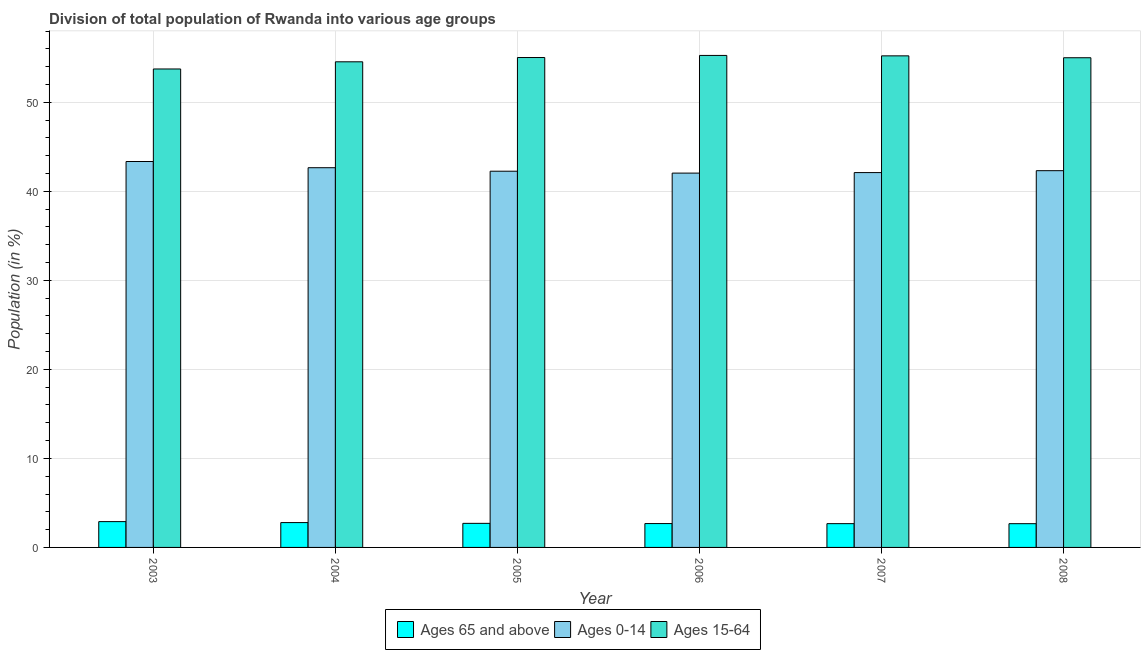How many different coloured bars are there?
Keep it short and to the point. 3. How many groups of bars are there?
Offer a terse response. 6. Are the number of bars on each tick of the X-axis equal?
Offer a very short reply. Yes. How many bars are there on the 1st tick from the right?
Provide a succinct answer. 3. In how many cases, is the number of bars for a given year not equal to the number of legend labels?
Keep it short and to the point. 0. What is the percentage of population within the age-group of 65 and above in 2003?
Keep it short and to the point. 2.9. Across all years, what is the maximum percentage of population within the age-group 15-64?
Your response must be concise. 55.27. Across all years, what is the minimum percentage of population within the age-group 0-14?
Keep it short and to the point. 42.05. In which year was the percentage of population within the age-group of 65 and above minimum?
Make the answer very short. 2008. What is the total percentage of population within the age-group of 65 and above in the graph?
Your answer should be compact. 16.42. What is the difference between the percentage of population within the age-group of 65 and above in 2003 and that in 2008?
Offer a very short reply. 0.23. What is the difference between the percentage of population within the age-group of 65 and above in 2006 and the percentage of population within the age-group 0-14 in 2005?
Your answer should be compact. -0.02. What is the average percentage of population within the age-group 0-14 per year?
Your response must be concise. 42.46. In the year 2008, what is the difference between the percentage of population within the age-group of 65 and above and percentage of population within the age-group 15-64?
Your answer should be compact. 0. What is the ratio of the percentage of population within the age-group 15-64 in 2004 to that in 2007?
Offer a very short reply. 0.99. Is the percentage of population within the age-group 0-14 in 2004 less than that in 2008?
Ensure brevity in your answer.  No. What is the difference between the highest and the second highest percentage of population within the age-group 0-14?
Your answer should be compact. 0.7. What is the difference between the highest and the lowest percentage of population within the age-group 15-64?
Provide a succinct answer. 1.52. What does the 1st bar from the left in 2007 represents?
Your answer should be very brief. Ages 65 and above. What does the 2nd bar from the right in 2008 represents?
Give a very brief answer. Ages 0-14. Is it the case that in every year, the sum of the percentage of population within the age-group of 65 and above and percentage of population within the age-group 0-14 is greater than the percentage of population within the age-group 15-64?
Ensure brevity in your answer.  No. How many bars are there?
Give a very brief answer. 18. How many years are there in the graph?
Ensure brevity in your answer.  6. What is the difference between two consecutive major ticks on the Y-axis?
Keep it short and to the point. 10. Are the values on the major ticks of Y-axis written in scientific E-notation?
Your response must be concise. No. Does the graph contain grids?
Ensure brevity in your answer.  Yes. Where does the legend appear in the graph?
Offer a very short reply. Bottom center. How many legend labels are there?
Ensure brevity in your answer.  3. How are the legend labels stacked?
Provide a succinct answer. Horizontal. What is the title of the graph?
Your answer should be very brief. Division of total population of Rwanda into various age groups
. What is the Population (in %) in Ages 65 and above in 2003?
Your response must be concise. 2.9. What is the Population (in %) in Ages 0-14 in 2003?
Keep it short and to the point. 43.35. What is the Population (in %) of Ages 15-64 in 2003?
Your answer should be compact. 53.75. What is the Population (in %) in Ages 65 and above in 2004?
Your answer should be very brief. 2.79. What is the Population (in %) in Ages 0-14 in 2004?
Your answer should be very brief. 42.66. What is the Population (in %) in Ages 15-64 in 2004?
Make the answer very short. 54.55. What is the Population (in %) in Ages 65 and above in 2005?
Keep it short and to the point. 2.71. What is the Population (in %) in Ages 0-14 in 2005?
Give a very brief answer. 42.26. What is the Population (in %) of Ages 15-64 in 2005?
Provide a short and direct response. 55.03. What is the Population (in %) in Ages 65 and above in 2006?
Provide a succinct answer. 2.68. What is the Population (in %) in Ages 0-14 in 2006?
Offer a very short reply. 42.05. What is the Population (in %) of Ages 15-64 in 2006?
Offer a very short reply. 55.27. What is the Population (in %) of Ages 65 and above in 2007?
Provide a succinct answer. 2.67. What is the Population (in %) in Ages 0-14 in 2007?
Give a very brief answer. 42.11. What is the Population (in %) of Ages 15-64 in 2007?
Provide a succinct answer. 55.22. What is the Population (in %) of Ages 65 and above in 2008?
Your answer should be compact. 2.67. What is the Population (in %) in Ages 0-14 in 2008?
Offer a very short reply. 42.32. What is the Population (in %) of Ages 15-64 in 2008?
Give a very brief answer. 55.01. Across all years, what is the maximum Population (in %) of Ages 65 and above?
Offer a very short reply. 2.9. Across all years, what is the maximum Population (in %) in Ages 0-14?
Your response must be concise. 43.35. Across all years, what is the maximum Population (in %) of Ages 15-64?
Offer a very short reply. 55.27. Across all years, what is the minimum Population (in %) in Ages 65 and above?
Your answer should be compact. 2.67. Across all years, what is the minimum Population (in %) of Ages 0-14?
Provide a succinct answer. 42.05. Across all years, what is the minimum Population (in %) in Ages 15-64?
Provide a short and direct response. 53.75. What is the total Population (in %) of Ages 65 and above in the graph?
Give a very brief answer. 16.42. What is the total Population (in %) of Ages 0-14 in the graph?
Make the answer very short. 254.75. What is the total Population (in %) of Ages 15-64 in the graph?
Ensure brevity in your answer.  328.83. What is the difference between the Population (in %) of Ages 65 and above in 2003 and that in 2004?
Your answer should be very brief. 0.11. What is the difference between the Population (in %) in Ages 0-14 in 2003 and that in 2004?
Keep it short and to the point. 0.7. What is the difference between the Population (in %) in Ages 15-64 in 2003 and that in 2004?
Your answer should be compact. -0.8. What is the difference between the Population (in %) of Ages 65 and above in 2003 and that in 2005?
Give a very brief answer. 0.19. What is the difference between the Population (in %) of Ages 0-14 in 2003 and that in 2005?
Your answer should be compact. 1.09. What is the difference between the Population (in %) of Ages 15-64 in 2003 and that in 2005?
Give a very brief answer. -1.29. What is the difference between the Population (in %) of Ages 65 and above in 2003 and that in 2006?
Provide a short and direct response. 0.22. What is the difference between the Population (in %) of Ages 0-14 in 2003 and that in 2006?
Keep it short and to the point. 1.3. What is the difference between the Population (in %) in Ages 15-64 in 2003 and that in 2006?
Offer a very short reply. -1.52. What is the difference between the Population (in %) of Ages 65 and above in 2003 and that in 2007?
Your answer should be very brief. 0.23. What is the difference between the Population (in %) of Ages 0-14 in 2003 and that in 2007?
Your answer should be very brief. 1.24. What is the difference between the Population (in %) in Ages 15-64 in 2003 and that in 2007?
Your response must be concise. -1.47. What is the difference between the Population (in %) in Ages 65 and above in 2003 and that in 2008?
Provide a short and direct response. 0.23. What is the difference between the Population (in %) in Ages 0-14 in 2003 and that in 2008?
Ensure brevity in your answer.  1.03. What is the difference between the Population (in %) in Ages 15-64 in 2003 and that in 2008?
Ensure brevity in your answer.  -1.26. What is the difference between the Population (in %) in Ages 65 and above in 2004 and that in 2005?
Keep it short and to the point. 0.09. What is the difference between the Population (in %) of Ages 0-14 in 2004 and that in 2005?
Your answer should be very brief. 0.39. What is the difference between the Population (in %) of Ages 15-64 in 2004 and that in 2005?
Your answer should be compact. -0.48. What is the difference between the Population (in %) in Ages 65 and above in 2004 and that in 2006?
Your response must be concise. 0.11. What is the difference between the Population (in %) in Ages 0-14 in 2004 and that in 2006?
Provide a short and direct response. 0.61. What is the difference between the Population (in %) in Ages 15-64 in 2004 and that in 2006?
Offer a very short reply. -0.72. What is the difference between the Population (in %) of Ages 65 and above in 2004 and that in 2007?
Make the answer very short. 0.12. What is the difference between the Population (in %) in Ages 0-14 in 2004 and that in 2007?
Ensure brevity in your answer.  0.55. What is the difference between the Population (in %) in Ages 15-64 in 2004 and that in 2007?
Your answer should be compact. -0.67. What is the difference between the Population (in %) of Ages 65 and above in 2004 and that in 2008?
Give a very brief answer. 0.12. What is the difference between the Population (in %) of Ages 0-14 in 2004 and that in 2008?
Give a very brief answer. 0.33. What is the difference between the Population (in %) in Ages 15-64 in 2004 and that in 2008?
Provide a short and direct response. -0.46. What is the difference between the Population (in %) of Ages 65 and above in 2005 and that in 2006?
Ensure brevity in your answer.  0.02. What is the difference between the Population (in %) of Ages 0-14 in 2005 and that in 2006?
Keep it short and to the point. 0.21. What is the difference between the Population (in %) of Ages 15-64 in 2005 and that in 2006?
Provide a short and direct response. -0.24. What is the difference between the Population (in %) in Ages 65 and above in 2005 and that in 2007?
Your answer should be compact. 0.03. What is the difference between the Population (in %) in Ages 0-14 in 2005 and that in 2007?
Provide a short and direct response. 0.15. What is the difference between the Population (in %) in Ages 15-64 in 2005 and that in 2007?
Keep it short and to the point. -0.19. What is the difference between the Population (in %) in Ages 65 and above in 2005 and that in 2008?
Offer a terse response. 0.04. What is the difference between the Population (in %) of Ages 0-14 in 2005 and that in 2008?
Make the answer very short. -0.06. What is the difference between the Population (in %) in Ages 15-64 in 2005 and that in 2008?
Offer a terse response. 0.02. What is the difference between the Population (in %) of Ages 65 and above in 2006 and that in 2007?
Offer a very short reply. 0.01. What is the difference between the Population (in %) of Ages 0-14 in 2006 and that in 2007?
Your response must be concise. -0.06. What is the difference between the Population (in %) in Ages 15-64 in 2006 and that in 2007?
Your answer should be very brief. 0.05. What is the difference between the Population (in %) of Ages 65 and above in 2006 and that in 2008?
Offer a terse response. 0.01. What is the difference between the Population (in %) of Ages 0-14 in 2006 and that in 2008?
Your response must be concise. -0.27. What is the difference between the Population (in %) in Ages 15-64 in 2006 and that in 2008?
Ensure brevity in your answer.  0.26. What is the difference between the Population (in %) of Ages 65 and above in 2007 and that in 2008?
Provide a short and direct response. 0. What is the difference between the Population (in %) in Ages 0-14 in 2007 and that in 2008?
Make the answer very short. -0.21. What is the difference between the Population (in %) in Ages 15-64 in 2007 and that in 2008?
Your answer should be compact. 0.21. What is the difference between the Population (in %) in Ages 65 and above in 2003 and the Population (in %) in Ages 0-14 in 2004?
Offer a terse response. -39.76. What is the difference between the Population (in %) in Ages 65 and above in 2003 and the Population (in %) in Ages 15-64 in 2004?
Your response must be concise. -51.65. What is the difference between the Population (in %) in Ages 0-14 in 2003 and the Population (in %) in Ages 15-64 in 2004?
Give a very brief answer. -11.2. What is the difference between the Population (in %) in Ages 65 and above in 2003 and the Population (in %) in Ages 0-14 in 2005?
Offer a terse response. -39.36. What is the difference between the Population (in %) of Ages 65 and above in 2003 and the Population (in %) of Ages 15-64 in 2005?
Provide a short and direct response. -52.13. What is the difference between the Population (in %) of Ages 0-14 in 2003 and the Population (in %) of Ages 15-64 in 2005?
Ensure brevity in your answer.  -11.68. What is the difference between the Population (in %) in Ages 65 and above in 2003 and the Population (in %) in Ages 0-14 in 2006?
Provide a succinct answer. -39.15. What is the difference between the Population (in %) in Ages 65 and above in 2003 and the Population (in %) in Ages 15-64 in 2006?
Your response must be concise. -52.37. What is the difference between the Population (in %) of Ages 0-14 in 2003 and the Population (in %) of Ages 15-64 in 2006?
Your answer should be compact. -11.92. What is the difference between the Population (in %) in Ages 65 and above in 2003 and the Population (in %) in Ages 0-14 in 2007?
Ensure brevity in your answer.  -39.21. What is the difference between the Population (in %) in Ages 65 and above in 2003 and the Population (in %) in Ages 15-64 in 2007?
Offer a very short reply. -52.32. What is the difference between the Population (in %) in Ages 0-14 in 2003 and the Population (in %) in Ages 15-64 in 2007?
Provide a succinct answer. -11.87. What is the difference between the Population (in %) of Ages 65 and above in 2003 and the Population (in %) of Ages 0-14 in 2008?
Offer a very short reply. -39.42. What is the difference between the Population (in %) in Ages 65 and above in 2003 and the Population (in %) in Ages 15-64 in 2008?
Give a very brief answer. -52.11. What is the difference between the Population (in %) of Ages 0-14 in 2003 and the Population (in %) of Ages 15-64 in 2008?
Make the answer very short. -11.66. What is the difference between the Population (in %) of Ages 65 and above in 2004 and the Population (in %) of Ages 0-14 in 2005?
Your answer should be compact. -39.47. What is the difference between the Population (in %) of Ages 65 and above in 2004 and the Population (in %) of Ages 15-64 in 2005?
Provide a short and direct response. -52.24. What is the difference between the Population (in %) of Ages 0-14 in 2004 and the Population (in %) of Ages 15-64 in 2005?
Your response must be concise. -12.38. What is the difference between the Population (in %) of Ages 65 and above in 2004 and the Population (in %) of Ages 0-14 in 2006?
Make the answer very short. -39.26. What is the difference between the Population (in %) in Ages 65 and above in 2004 and the Population (in %) in Ages 15-64 in 2006?
Your response must be concise. -52.48. What is the difference between the Population (in %) of Ages 0-14 in 2004 and the Population (in %) of Ages 15-64 in 2006?
Make the answer very short. -12.61. What is the difference between the Population (in %) of Ages 65 and above in 2004 and the Population (in %) of Ages 0-14 in 2007?
Provide a short and direct response. -39.32. What is the difference between the Population (in %) in Ages 65 and above in 2004 and the Population (in %) in Ages 15-64 in 2007?
Provide a succinct answer. -52.43. What is the difference between the Population (in %) of Ages 0-14 in 2004 and the Population (in %) of Ages 15-64 in 2007?
Make the answer very short. -12.57. What is the difference between the Population (in %) of Ages 65 and above in 2004 and the Population (in %) of Ages 0-14 in 2008?
Offer a very short reply. -39.53. What is the difference between the Population (in %) of Ages 65 and above in 2004 and the Population (in %) of Ages 15-64 in 2008?
Ensure brevity in your answer.  -52.22. What is the difference between the Population (in %) of Ages 0-14 in 2004 and the Population (in %) of Ages 15-64 in 2008?
Keep it short and to the point. -12.35. What is the difference between the Population (in %) in Ages 65 and above in 2005 and the Population (in %) in Ages 0-14 in 2006?
Give a very brief answer. -39.35. What is the difference between the Population (in %) in Ages 65 and above in 2005 and the Population (in %) in Ages 15-64 in 2006?
Offer a terse response. -52.56. What is the difference between the Population (in %) of Ages 0-14 in 2005 and the Population (in %) of Ages 15-64 in 2006?
Keep it short and to the point. -13.01. What is the difference between the Population (in %) in Ages 65 and above in 2005 and the Population (in %) in Ages 0-14 in 2007?
Your answer should be compact. -39.4. What is the difference between the Population (in %) in Ages 65 and above in 2005 and the Population (in %) in Ages 15-64 in 2007?
Keep it short and to the point. -52.52. What is the difference between the Population (in %) in Ages 0-14 in 2005 and the Population (in %) in Ages 15-64 in 2007?
Give a very brief answer. -12.96. What is the difference between the Population (in %) of Ages 65 and above in 2005 and the Population (in %) of Ages 0-14 in 2008?
Offer a terse response. -39.62. What is the difference between the Population (in %) of Ages 65 and above in 2005 and the Population (in %) of Ages 15-64 in 2008?
Offer a terse response. -52.3. What is the difference between the Population (in %) in Ages 0-14 in 2005 and the Population (in %) in Ages 15-64 in 2008?
Give a very brief answer. -12.75. What is the difference between the Population (in %) of Ages 65 and above in 2006 and the Population (in %) of Ages 0-14 in 2007?
Your response must be concise. -39.43. What is the difference between the Population (in %) in Ages 65 and above in 2006 and the Population (in %) in Ages 15-64 in 2007?
Give a very brief answer. -52.54. What is the difference between the Population (in %) of Ages 0-14 in 2006 and the Population (in %) of Ages 15-64 in 2007?
Keep it short and to the point. -13.17. What is the difference between the Population (in %) of Ages 65 and above in 2006 and the Population (in %) of Ages 0-14 in 2008?
Make the answer very short. -39.64. What is the difference between the Population (in %) in Ages 65 and above in 2006 and the Population (in %) in Ages 15-64 in 2008?
Offer a terse response. -52.33. What is the difference between the Population (in %) in Ages 0-14 in 2006 and the Population (in %) in Ages 15-64 in 2008?
Your answer should be compact. -12.96. What is the difference between the Population (in %) of Ages 65 and above in 2007 and the Population (in %) of Ages 0-14 in 2008?
Offer a terse response. -39.65. What is the difference between the Population (in %) of Ages 65 and above in 2007 and the Population (in %) of Ages 15-64 in 2008?
Your answer should be compact. -52.34. What is the difference between the Population (in %) in Ages 0-14 in 2007 and the Population (in %) in Ages 15-64 in 2008?
Give a very brief answer. -12.9. What is the average Population (in %) of Ages 65 and above per year?
Make the answer very short. 2.74. What is the average Population (in %) in Ages 0-14 per year?
Your answer should be compact. 42.46. What is the average Population (in %) in Ages 15-64 per year?
Give a very brief answer. 54.81. In the year 2003, what is the difference between the Population (in %) of Ages 65 and above and Population (in %) of Ages 0-14?
Keep it short and to the point. -40.45. In the year 2003, what is the difference between the Population (in %) in Ages 65 and above and Population (in %) in Ages 15-64?
Provide a succinct answer. -50.85. In the year 2003, what is the difference between the Population (in %) in Ages 0-14 and Population (in %) in Ages 15-64?
Provide a succinct answer. -10.4. In the year 2004, what is the difference between the Population (in %) in Ages 65 and above and Population (in %) in Ages 0-14?
Your answer should be compact. -39.87. In the year 2004, what is the difference between the Population (in %) in Ages 65 and above and Population (in %) in Ages 15-64?
Offer a terse response. -51.76. In the year 2004, what is the difference between the Population (in %) in Ages 0-14 and Population (in %) in Ages 15-64?
Keep it short and to the point. -11.9. In the year 2005, what is the difference between the Population (in %) of Ages 65 and above and Population (in %) of Ages 0-14?
Provide a succinct answer. -39.56. In the year 2005, what is the difference between the Population (in %) of Ages 65 and above and Population (in %) of Ages 15-64?
Keep it short and to the point. -52.33. In the year 2005, what is the difference between the Population (in %) in Ages 0-14 and Population (in %) in Ages 15-64?
Offer a terse response. -12.77. In the year 2006, what is the difference between the Population (in %) in Ages 65 and above and Population (in %) in Ages 0-14?
Your answer should be very brief. -39.37. In the year 2006, what is the difference between the Population (in %) of Ages 65 and above and Population (in %) of Ages 15-64?
Offer a terse response. -52.59. In the year 2006, what is the difference between the Population (in %) in Ages 0-14 and Population (in %) in Ages 15-64?
Give a very brief answer. -13.22. In the year 2007, what is the difference between the Population (in %) in Ages 65 and above and Population (in %) in Ages 0-14?
Offer a very short reply. -39.44. In the year 2007, what is the difference between the Population (in %) of Ages 65 and above and Population (in %) of Ages 15-64?
Give a very brief answer. -52.55. In the year 2007, what is the difference between the Population (in %) in Ages 0-14 and Population (in %) in Ages 15-64?
Your response must be concise. -13.11. In the year 2008, what is the difference between the Population (in %) in Ages 65 and above and Population (in %) in Ages 0-14?
Provide a succinct answer. -39.65. In the year 2008, what is the difference between the Population (in %) in Ages 65 and above and Population (in %) in Ages 15-64?
Your answer should be compact. -52.34. In the year 2008, what is the difference between the Population (in %) in Ages 0-14 and Population (in %) in Ages 15-64?
Make the answer very short. -12.69. What is the ratio of the Population (in %) in Ages 65 and above in 2003 to that in 2004?
Keep it short and to the point. 1.04. What is the ratio of the Population (in %) in Ages 0-14 in 2003 to that in 2004?
Your answer should be very brief. 1.02. What is the ratio of the Population (in %) of Ages 15-64 in 2003 to that in 2004?
Make the answer very short. 0.99. What is the ratio of the Population (in %) in Ages 65 and above in 2003 to that in 2005?
Offer a terse response. 1.07. What is the ratio of the Population (in %) of Ages 0-14 in 2003 to that in 2005?
Keep it short and to the point. 1.03. What is the ratio of the Population (in %) of Ages 15-64 in 2003 to that in 2005?
Give a very brief answer. 0.98. What is the ratio of the Population (in %) in Ages 65 and above in 2003 to that in 2006?
Ensure brevity in your answer.  1.08. What is the ratio of the Population (in %) of Ages 0-14 in 2003 to that in 2006?
Keep it short and to the point. 1.03. What is the ratio of the Population (in %) in Ages 15-64 in 2003 to that in 2006?
Offer a terse response. 0.97. What is the ratio of the Population (in %) in Ages 65 and above in 2003 to that in 2007?
Keep it short and to the point. 1.09. What is the ratio of the Population (in %) in Ages 0-14 in 2003 to that in 2007?
Your response must be concise. 1.03. What is the ratio of the Population (in %) of Ages 15-64 in 2003 to that in 2007?
Keep it short and to the point. 0.97. What is the ratio of the Population (in %) of Ages 65 and above in 2003 to that in 2008?
Offer a very short reply. 1.09. What is the ratio of the Population (in %) in Ages 0-14 in 2003 to that in 2008?
Provide a short and direct response. 1.02. What is the ratio of the Population (in %) of Ages 15-64 in 2003 to that in 2008?
Ensure brevity in your answer.  0.98. What is the ratio of the Population (in %) in Ages 65 and above in 2004 to that in 2005?
Keep it short and to the point. 1.03. What is the ratio of the Population (in %) of Ages 0-14 in 2004 to that in 2005?
Your response must be concise. 1.01. What is the ratio of the Population (in %) in Ages 15-64 in 2004 to that in 2005?
Ensure brevity in your answer.  0.99. What is the ratio of the Population (in %) in Ages 65 and above in 2004 to that in 2006?
Provide a succinct answer. 1.04. What is the ratio of the Population (in %) in Ages 0-14 in 2004 to that in 2006?
Your answer should be very brief. 1.01. What is the ratio of the Population (in %) in Ages 15-64 in 2004 to that in 2006?
Make the answer very short. 0.99. What is the ratio of the Population (in %) in Ages 65 and above in 2004 to that in 2007?
Your answer should be very brief. 1.05. What is the ratio of the Population (in %) in Ages 0-14 in 2004 to that in 2007?
Your response must be concise. 1.01. What is the ratio of the Population (in %) in Ages 15-64 in 2004 to that in 2007?
Make the answer very short. 0.99. What is the ratio of the Population (in %) of Ages 65 and above in 2004 to that in 2008?
Ensure brevity in your answer.  1.05. What is the ratio of the Population (in %) of Ages 0-14 in 2004 to that in 2008?
Offer a very short reply. 1.01. What is the ratio of the Population (in %) in Ages 65 and above in 2005 to that in 2006?
Keep it short and to the point. 1.01. What is the ratio of the Population (in %) in Ages 65 and above in 2005 to that in 2007?
Provide a succinct answer. 1.01. What is the ratio of the Population (in %) in Ages 65 and above in 2005 to that in 2008?
Your response must be concise. 1.01. What is the ratio of the Population (in %) in Ages 0-14 in 2005 to that in 2008?
Make the answer very short. 1. What is the ratio of the Population (in %) of Ages 65 and above in 2006 to that in 2007?
Offer a terse response. 1. What is the ratio of the Population (in %) of Ages 0-14 in 2006 to that in 2007?
Provide a short and direct response. 1. What is the ratio of the Population (in %) of Ages 15-64 in 2006 to that in 2007?
Give a very brief answer. 1. What is the ratio of the Population (in %) of Ages 65 and above in 2006 to that in 2008?
Make the answer very short. 1. What is the ratio of the Population (in %) in Ages 15-64 in 2006 to that in 2008?
Provide a succinct answer. 1. What is the ratio of the Population (in %) in Ages 65 and above in 2007 to that in 2008?
Keep it short and to the point. 1. What is the ratio of the Population (in %) of Ages 0-14 in 2007 to that in 2008?
Give a very brief answer. 0.99. What is the ratio of the Population (in %) of Ages 15-64 in 2007 to that in 2008?
Offer a very short reply. 1. What is the difference between the highest and the second highest Population (in %) of Ages 65 and above?
Your response must be concise. 0.11. What is the difference between the highest and the second highest Population (in %) of Ages 0-14?
Your response must be concise. 0.7. What is the difference between the highest and the second highest Population (in %) of Ages 15-64?
Offer a very short reply. 0.05. What is the difference between the highest and the lowest Population (in %) of Ages 65 and above?
Provide a succinct answer. 0.23. What is the difference between the highest and the lowest Population (in %) of Ages 0-14?
Keep it short and to the point. 1.3. What is the difference between the highest and the lowest Population (in %) in Ages 15-64?
Your response must be concise. 1.52. 